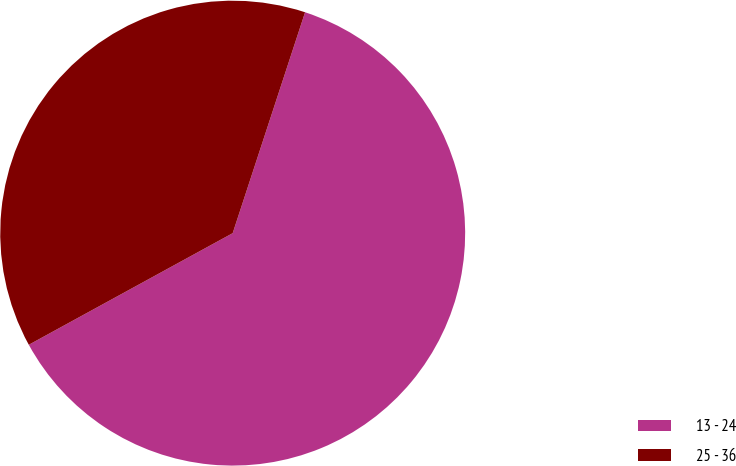<chart> <loc_0><loc_0><loc_500><loc_500><pie_chart><fcel>13 - 24<fcel>25 - 36<nl><fcel>61.99%<fcel>38.01%<nl></chart> 